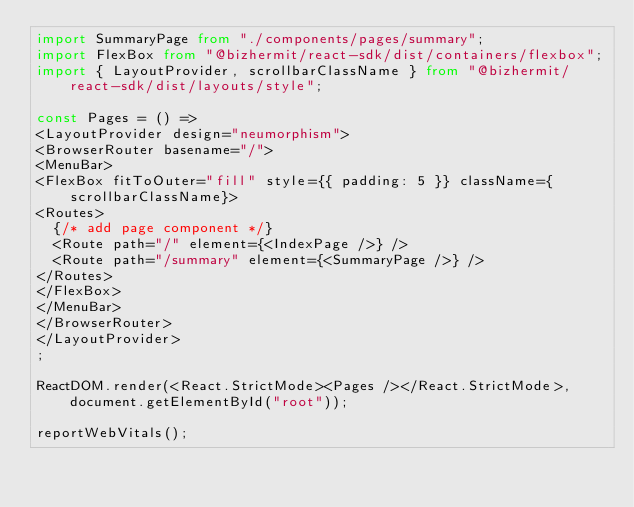Convert code to text. <code><loc_0><loc_0><loc_500><loc_500><_TypeScript_>import SummaryPage from "./components/pages/summary";
import FlexBox from "@bizhermit/react-sdk/dist/containers/flexbox";
import { LayoutProvider, scrollbarClassName } from "@bizhermit/react-sdk/dist/layouts/style";

const Pages = () => 
<LayoutProvider design="neumorphism">
<BrowserRouter basename="/">
<MenuBar>
<FlexBox fitToOuter="fill" style={{ padding: 5 }} className={scrollbarClassName}>
<Routes>
  {/* add page component */}
  <Route path="/" element={<IndexPage />} />
  <Route path="/summary" element={<SummaryPage />} />
</Routes>
</FlexBox>
</MenuBar>
</BrowserRouter>
</LayoutProvider>
;

ReactDOM.render(<React.StrictMode><Pages /></React.StrictMode>, document.getElementById("root"));

reportWebVitals();</code> 